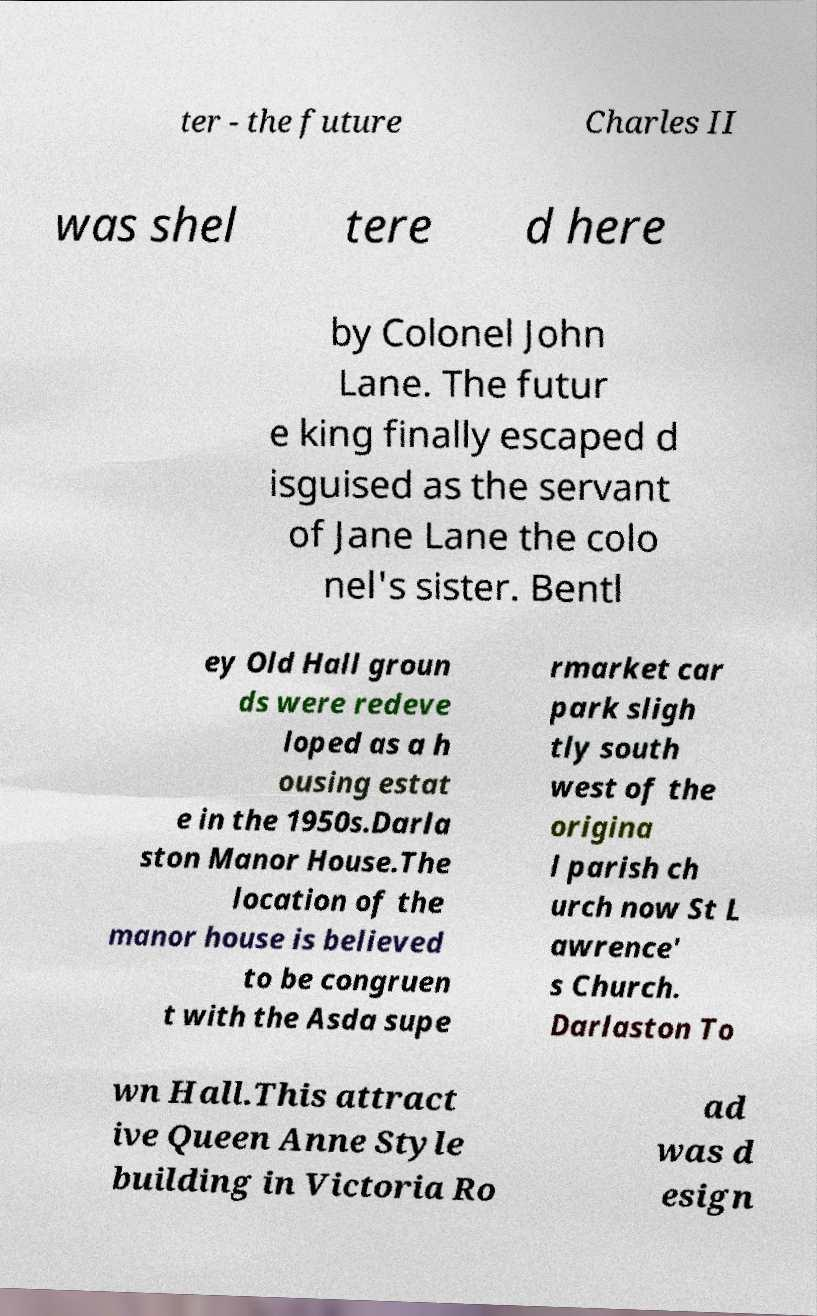Can you read and provide the text displayed in the image?This photo seems to have some interesting text. Can you extract and type it out for me? ter - the future Charles II was shel tere d here by Colonel John Lane. The futur e king finally escaped d isguised as the servant of Jane Lane the colo nel's sister. Bentl ey Old Hall groun ds were redeve loped as a h ousing estat e in the 1950s.Darla ston Manor House.The location of the manor house is believed to be congruen t with the Asda supe rmarket car park sligh tly south west of the origina l parish ch urch now St L awrence' s Church. Darlaston To wn Hall.This attract ive Queen Anne Style building in Victoria Ro ad was d esign 